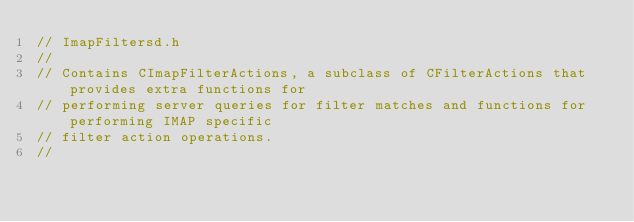Convert code to text. <code><loc_0><loc_0><loc_500><loc_500><_C_>// ImapFiltersd.h
//
// Contains CImapFilterActions, a subclass of CFilterActions that provides extra functions for
// performing server queries for filter matches and functions for performing IMAP specific
// filter action operations.
//</code> 